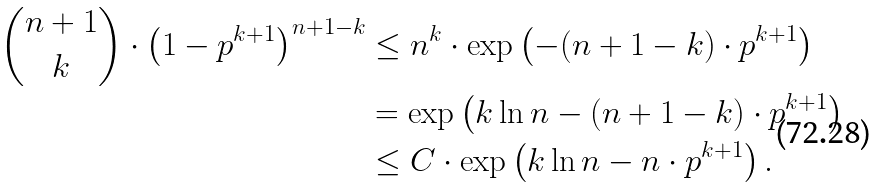<formula> <loc_0><loc_0><loc_500><loc_500>\binom { n + 1 } { k } \cdot \left ( 1 - p ^ { k + 1 } \right ) ^ { n + 1 - k } & \leq n ^ { k } \cdot \exp \left ( - ( n + 1 - k ) \cdot p ^ { k + 1 } \right ) \\ & = \exp \left ( k \ln n - ( n + 1 - k ) \cdot p ^ { k + 1 } \right ) \\ & \leq C \cdot \exp \left ( k \ln n - n \cdot p ^ { k + 1 } \right ) .</formula> 